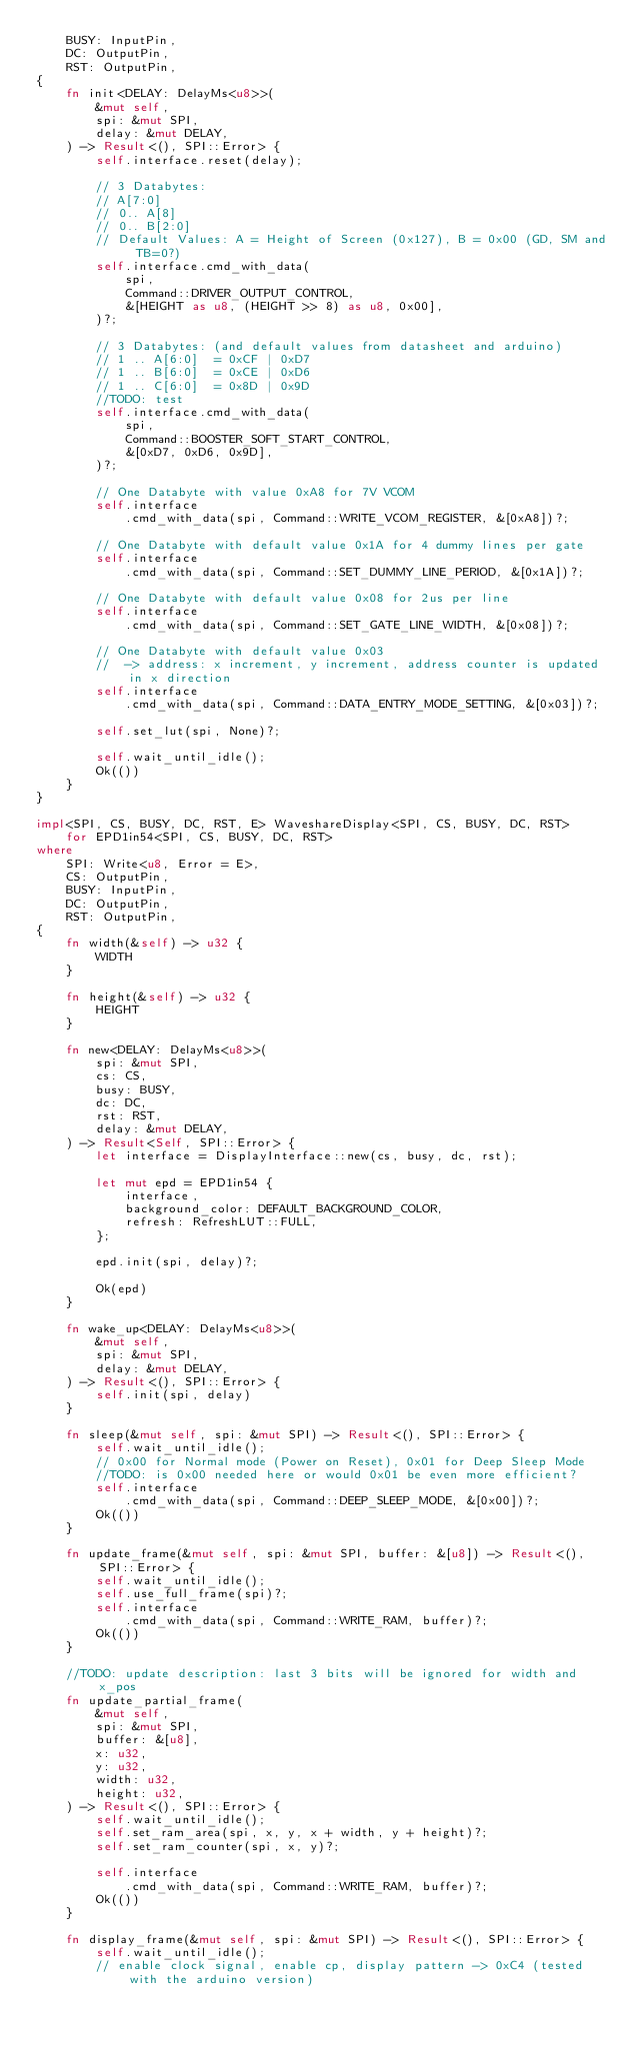Convert code to text. <code><loc_0><loc_0><loc_500><loc_500><_Rust_>    BUSY: InputPin,
    DC: OutputPin,
    RST: OutputPin,
{
    fn init<DELAY: DelayMs<u8>>(
        &mut self,
        spi: &mut SPI,
        delay: &mut DELAY,
    ) -> Result<(), SPI::Error> {
        self.interface.reset(delay);

        // 3 Databytes:
        // A[7:0]
        // 0.. A[8]
        // 0.. B[2:0]
        // Default Values: A = Height of Screen (0x127), B = 0x00 (GD, SM and TB=0?)
        self.interface.cmd_with_data(
            spi,
            Command::DRIVER_OUTPUT_CONTROL,
            &[HEIGHT as u8, (HEIGHT >> 8) as u8, 0x00],
        )?;

        // 3 Databytes: (and default values from datasheet and arduino)
        // 1 .. A[6:0]  = 0xCF | 0xD7
        // 1 .. B[6:0]  = 0xCE | 0xD6
        // 1 .. C[6:0]  = 0x8D | 0x9D
        //TODO: test
        self.interface.cmd_with_data(
            spi,
            Command::BOOSTER_SOFT_START_CONTROL,
            &[0xD7, 0xD6, 0x9D],
        )?;

        // One Databyte with value 0xA8 for 7V VCOM
        self.interface
            .cmd_with_data(spi, Command::WRITE_VCOM_REGISTER, &[0xA8])?;

        // One Databyte with default value 0x1A for 4 dummy lines per gate
        self.interface
            .cmd_with_data(spi, Command::SET_DUMMY_LINE_PERIOD, &[0x1A])?;

        // One Databyte with default value 0x08 for 2us per line
        self.interface
            .cmd_with_data(spi, Command::SET_GATE_LINE_WIDTH, &[0x08])?;

        // One Databyte with default value 0x03
        //  -> address: x increment, y increment, address counter is updated in x direction
        self.interface
            .cmd_with_data(spi, Command::DATA_ENTRY_MODE_SETTING, &[0x03])?;

        self.set_lut(spi, None)?;

        self.wait_until_idle();
        Ok(())
    }
}

impl<SPI, CS, BUSY, DC, RST, E> WaveshareDisplay<SPI, CS, BUSY, DC, RST>
    for EPD1in54<SPI, CS, BUSY, DC, RST>
where
    SPI: Write<u8, Error = E>,
    CS: OutputPin,
    BUSY: InputPin,
    DC: OutputPin,
    RST: OutputPin,
{
    fn width(&self) -> u32 {
        WIDTH
    }

    fn height(&self) -> u32 {
        HEIGHT
    }

    fn new<DELAY: DelayMs<u8>>(
        spi: &mut SPI,
        cs: CS,
        busy: BUSY,
        dc: DC,
        rst: RST,
        delay: &mut DELAY,
    ) -> Result<Self, SPI::Error> {
        let interface = DisplayInterface::new(cs, busy, dc, rst);

        let mut epd = EPD1in54 {
            interface,
            background_color: DEFAULT_BACKGROUND_COLOR,
            refresh: RefreshLUT::FULL,
        };

        epd.init(spi, delay)?;

        Ok(epd)
    }

    fn wake_up<DELAY: DelayMs<u8>>(
        &mut self,
        spi: &mut SPI,
        delay: &mut DELAY,
    ) -> Result<(), SPI::Error> {
        self.init(spi, delay)
    }

    fn sleep(&mut self, spi: &mut SPI) -> Result<(), SPI::Error> {
        self.wait_until_idle();
        // 0x00 for Normal mode (Power on Reset), 0x01 for Deep Sleep Mode
        //TODO: is 0x00 needed here or would 0x01 be even more efficient?
        self.interface
            .cmd_with_data(spi, Command::DEEP_SLEEP_MODE, &[0x00])?;
        Ok(())
    }

    fn update_frame(&mut self, spi: &mut SPI, buffer: &[u8]) -> Result<(), SPI::Error> {
        self.wait_until_idle();
        self.use_full_frame(spi)?;
        self.interface
            .cmd_with_data(spi, Command::WRITE_RAM, buffer)?;
        Ok(())
    }

    //TODO: update description: last 3 bits will be ignored for width and x_pos
    fn update_partial_frame(
        &mut self,
        spi: &mut SPI,
        buffer: &[u8],
        x: u32,
        y: u32,
        width: u32,
        height: u32,
    ) -> Result<(), SPI::Error> {
        self.wait_until_idle();
        self.set_ram_area(spi, x, y, x + width, y + height)?;
        self.set_ram_counter(spi, x, y)?;

        self.interface
            .cmd_with_data(spi, Command::WRITE_RAM, buffer)?;
        Ok(())
    }

    fn display_frame(&mut self, spi: &mut SPI) -> Result<(), SPI::Error> {
        self.wait_until_idle();
        // enable clock signal, enable cp, display pattern -> 0xC4 (tested with the arduino version)</code> 